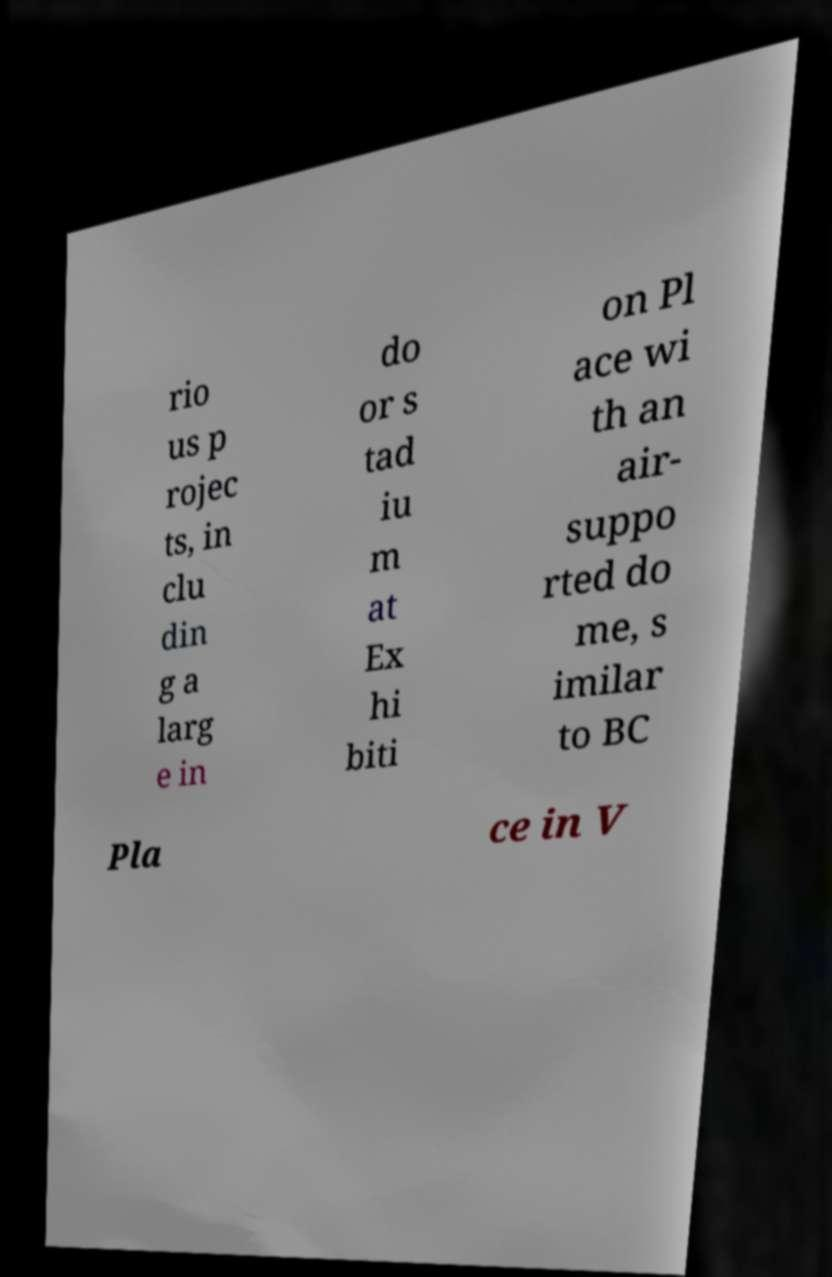Please read and relay the text visible in this image. What does it say? rio us p rojec ts, in clu din g a larg e in do or s tad iu m at Ex hi biti on Pl ace wi th an air- suppo rted do me, s imilar to BC Pla ce in V 